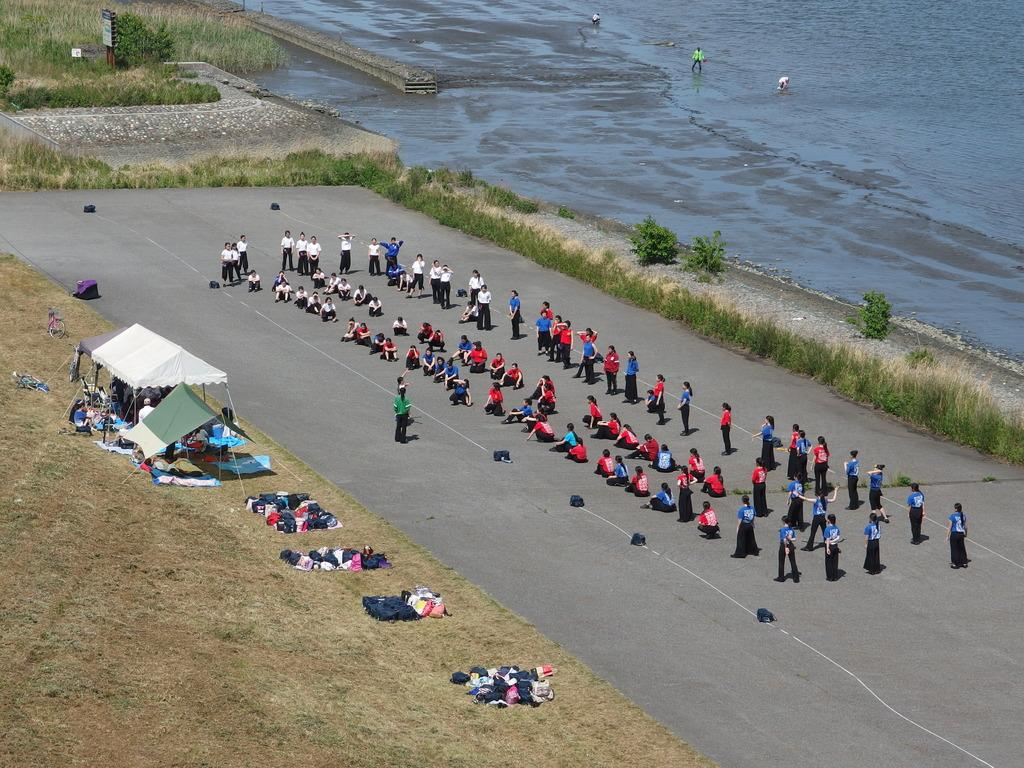What can be seen on the road in the image? There is a group of people on the road in the image. What type of temporary shelter is present in the image? There are tents in the image. What items can be seen that might be used for carrying belongings? There are bags in the image. What type of natural environment is visible in the image? Grass and plants are visible in the image. What body of water can be seen in the image? There is water visible at the top of the image. Are there people near the water in the image? Yes, there are people near the water in the image. What type of cream is being spread on the bread in the image? There is no bread or cream present in the image. What type of meal is being prepared by the people near the water in the image? There is no meal preparation visible in the image; the people near the water are not shown engaging in any food-related activities. 